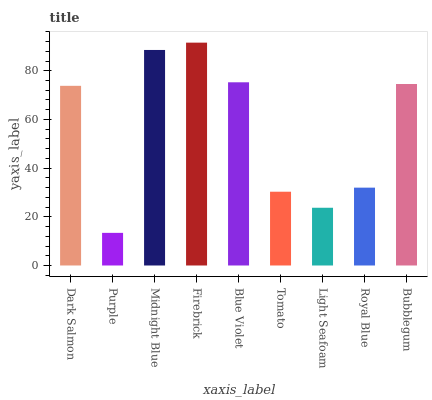Is Midnight Blue the minimum?
Answer yes or no. No. Is Midnight Blue the maximum?
Answer yes or no. No. Is Midnight Blue greater than Purple?
Answer yes or no. Yes. Is Purple less than Midnight Blue?
Answer yes or no. Yes. Is Purple greater than Midnight Blue?
Answer yes or no. No. Is Midnight Blue less than Purple?
Answer yes or no. No. Is Dark Salmon the high median?
Answer yes or no. Yes. Is Dark Salmon the low median?
Answer yes or no. Yes. Is Purple the high median?
Answer yes or no. No. Is Bubblegum the low median?
Answer yes or no. No. 